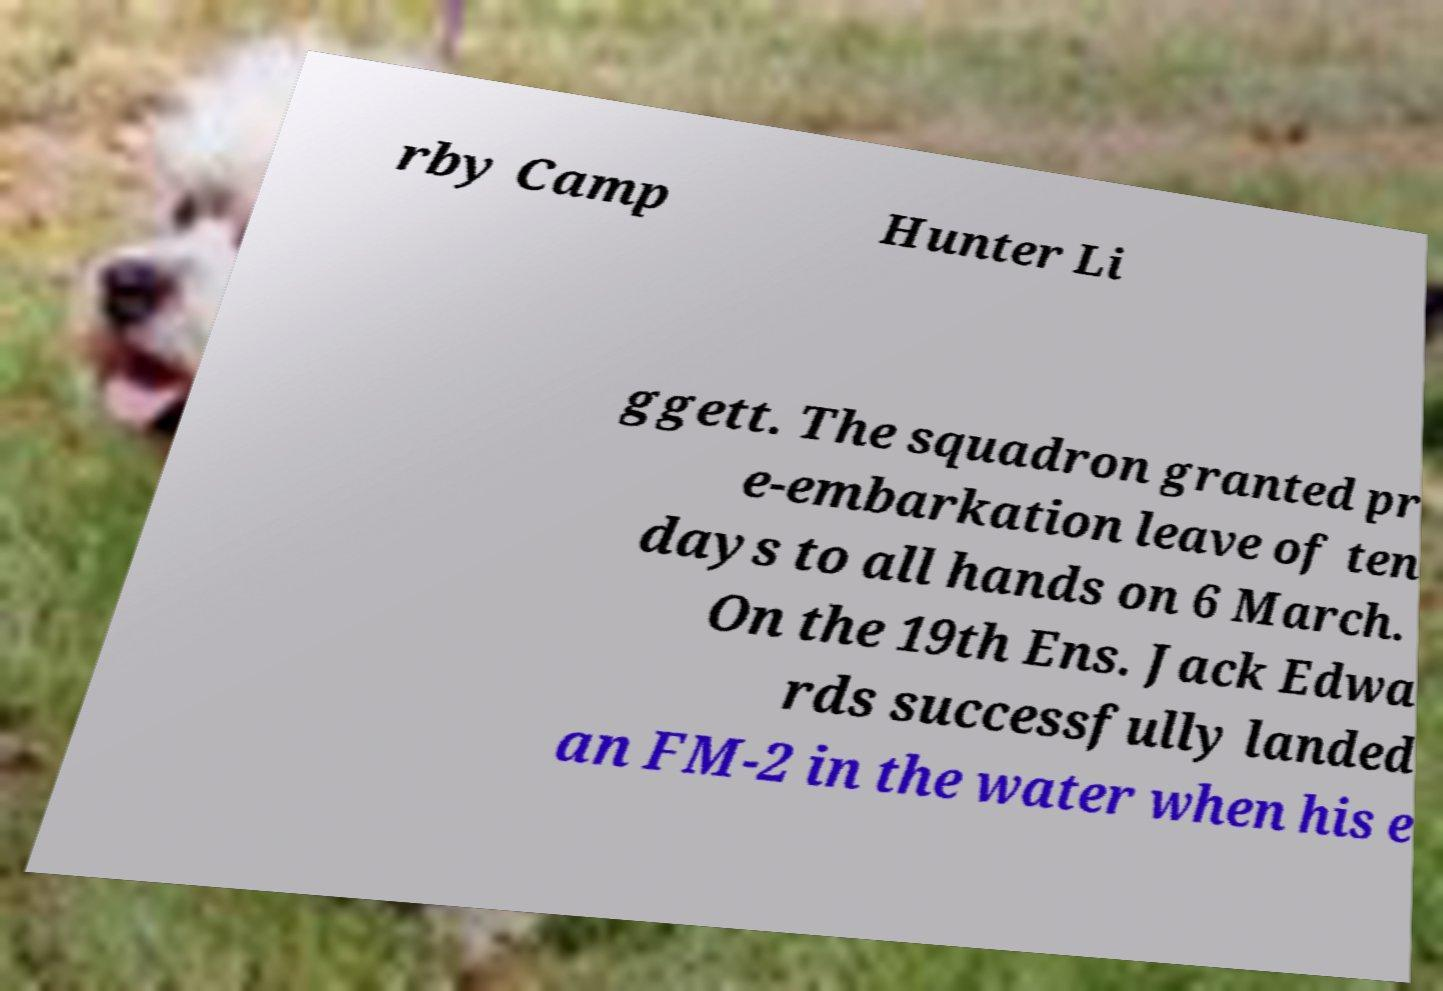Could you assist in decoding the text presented in this image and type it out clearly? rby Camp Hunter Li ggett. The squadron granted pr e-embarkation leave of ten days to all hands on 6 March. On the 19th Ens. Jack Edwa rds successfully landed an FM-2 in the water when his e 